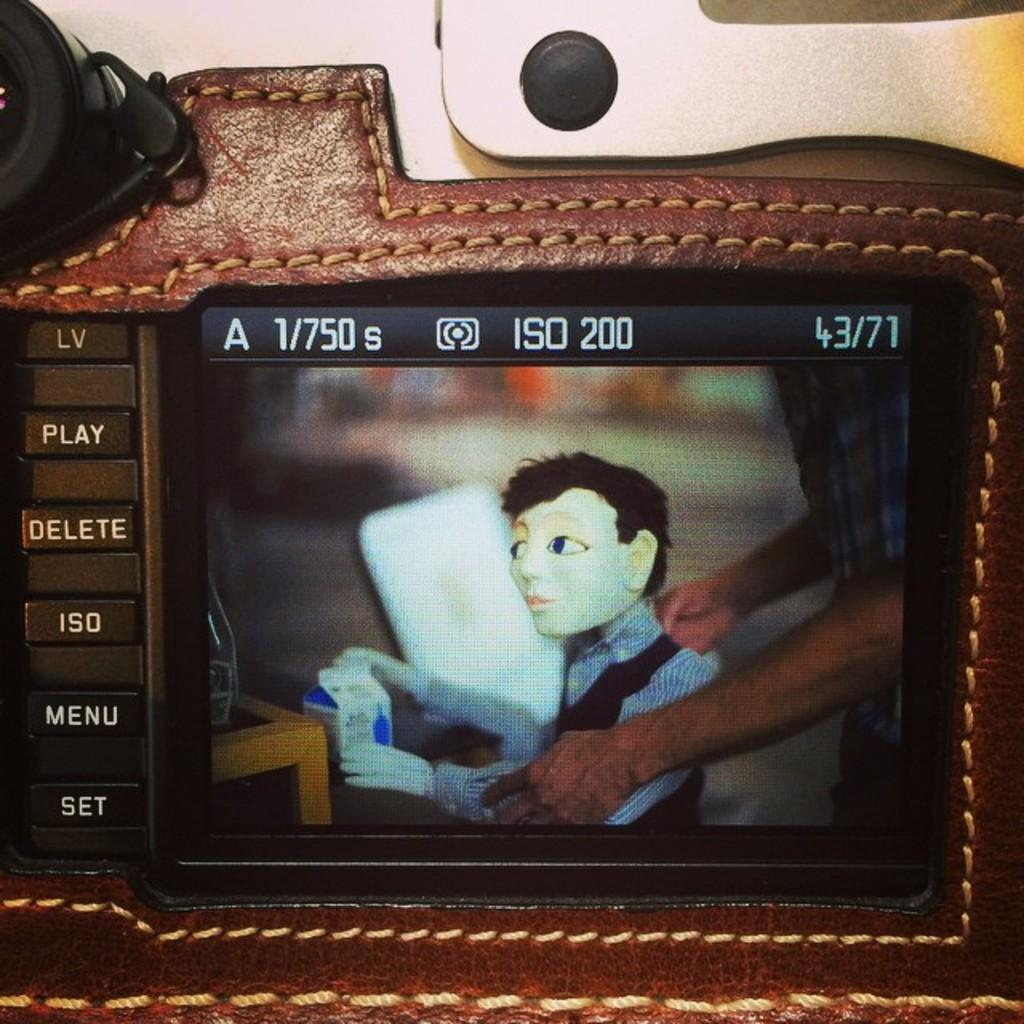What object is the main focus of the picture? There is a camera in the picture. What is visible on the camera's screen? The camera's screen displays a person's hands. What are the person's hands holding? The person's hands are holding a toy. How many kittens are sitting on the shelf in the image? There are no kittens or shelves present in the image; it features a camera with a person's hands holding a toy on its screen. 